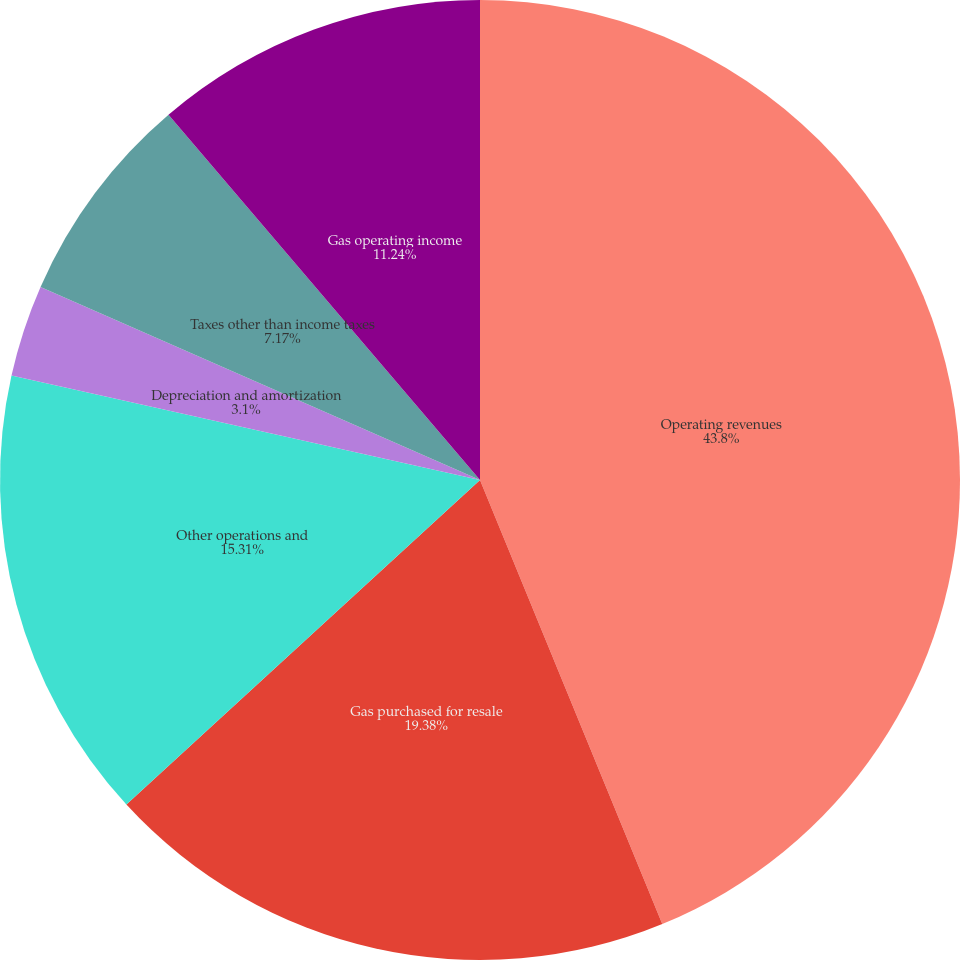Convert chart. <chart><loc_0><loc_0><loc_500><loc_500><pie_chart><fcel>Operating revenues<fcel>Gas purchased for resale<fcel>Other operations and<fcel>Depreciation and amortization<fcel>Taxes other than income taxes<fcel>Gas operating income<nl><fcel>43.8%<fcel>19.38%<fcel>15.31%<fcel>3.1%<fcel>7.17%<fcel>11.24%<nl></chart> 